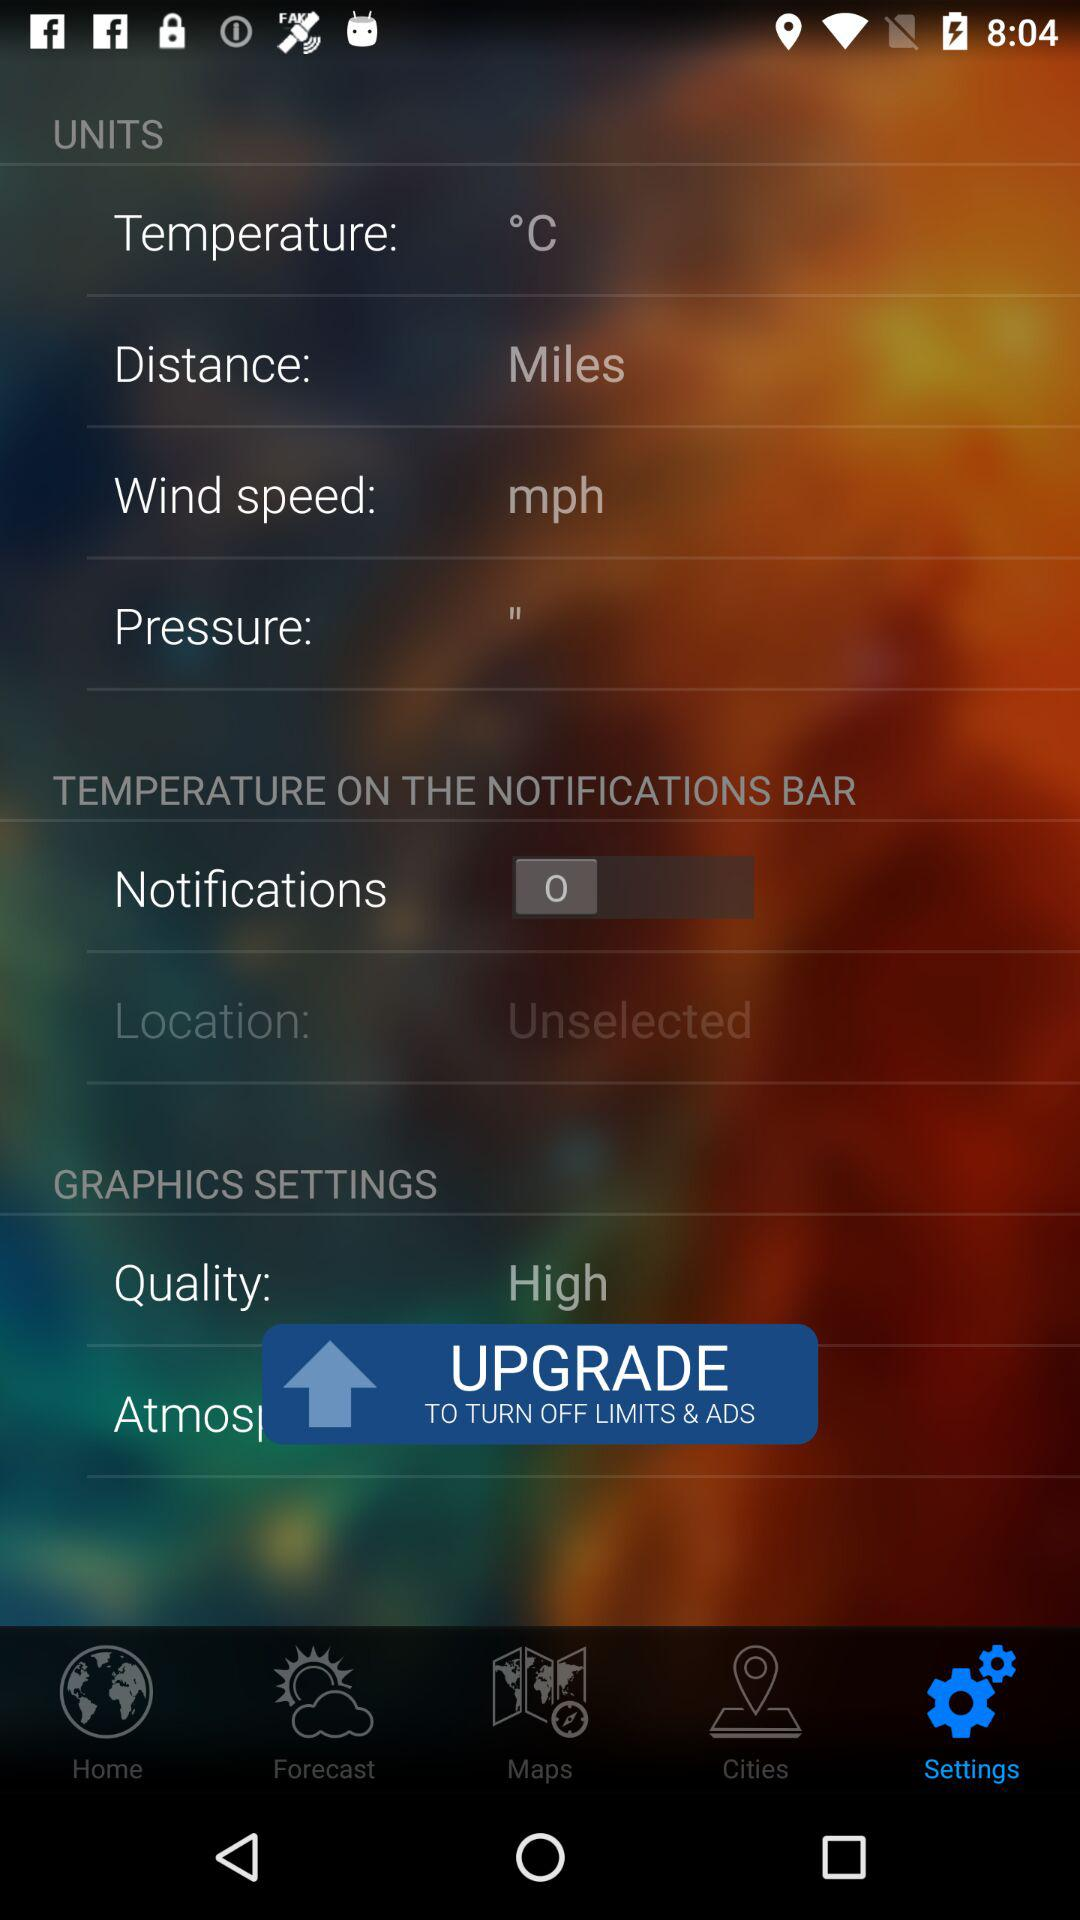What is the setting for the location? The setting is "Unselected". 